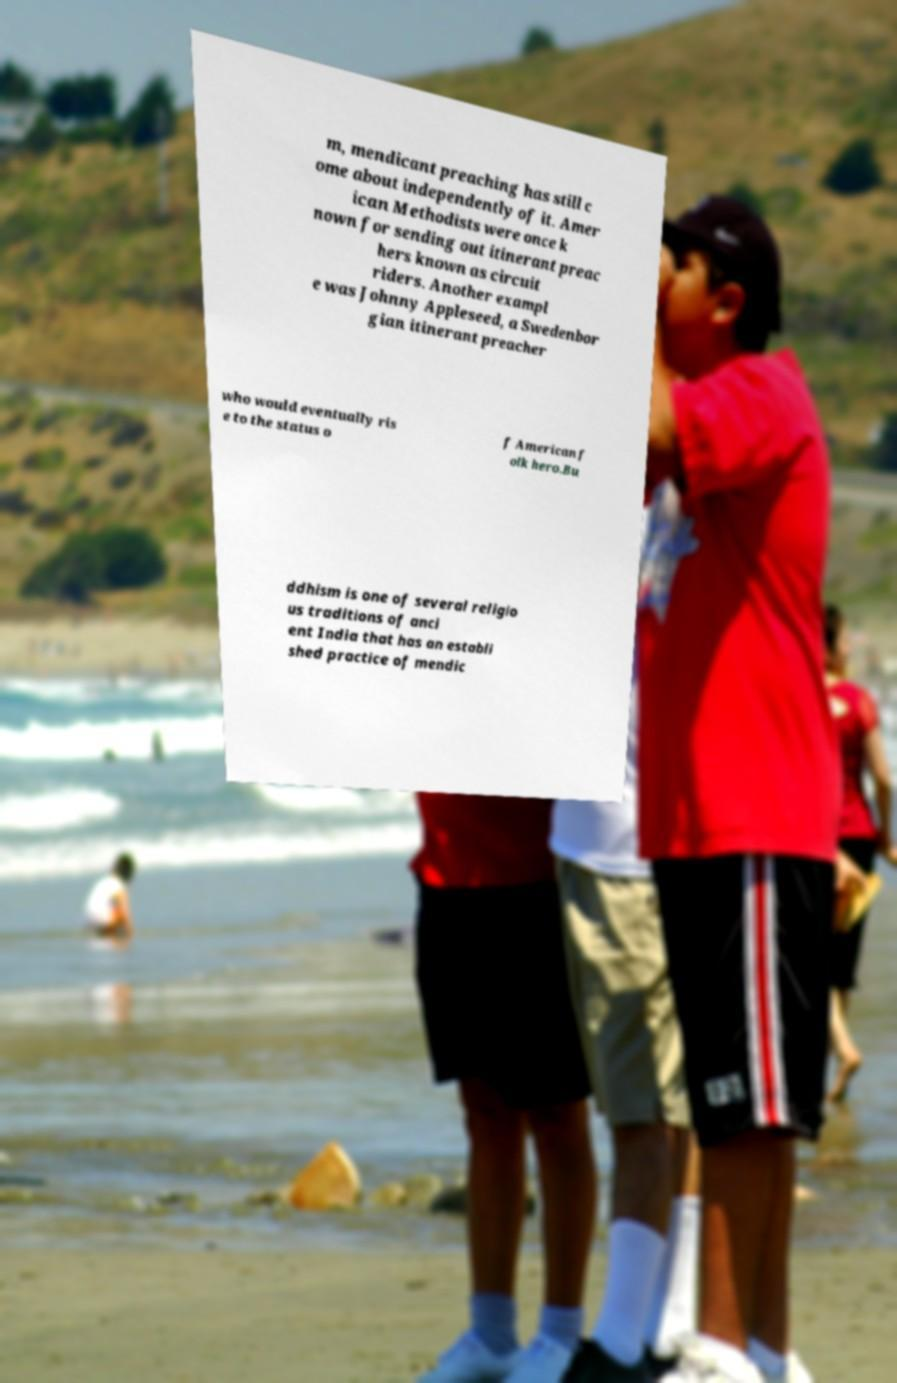Please identify and transcribe the text found in this image. m, mendicant preaching has still c ome about independently of it. Amer ican Methodists were once k nown for sending out itinerant preac hers known as circuit riders. Another exampl e was Johnny Appleseed, a Swedenbor gian itinerant preacher who would eventually ris e to the status o f American f olk hero.Bu ddhism is one of several religio us traditions of anci ent India that has an establi shed practice of mendic 